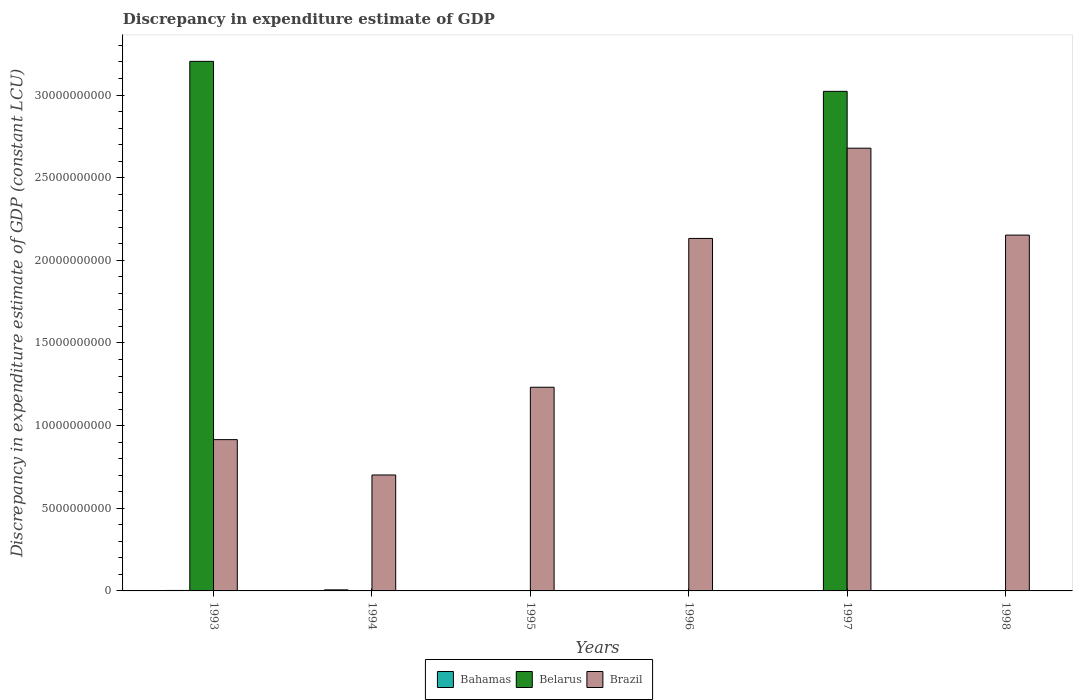How many different coloured bars are there?
Offer a terse response. 3. Are the number of bars per tick equal to the number of legend labels?
Offer a very short reply. No. Are the number of bars on each tick of the X-axis equal?
Offer a very short reply. No. What is the discrepancy in expenditure estimate of GDP in Brazil in 1996?
Your answer should be very brief. 2.13e+1. Across all years, what is the maximum discrepancy in expenditure estimate of GDP in Bahamas?
Make the answer very short. 6.38e+07. Across all years, what is the minimum discrepancy in expenditure estimate of GDP in Brazil?
Your answer should be very brief. 7.01e+09. What is the total discrepancy in expenditure estimate of GDP in Belarus in the graph?
Keep it short and to the point. 6.23e+1. What is the difference between the discrepancy in expenditure estimate of GDP in Belarus in 1993 and that in 1997?
Provide a short and direct response. 1.81e+09. What is the difference between the discrepancy in expenditure estimate of GDP in Belarus in 1998 and the discrepancy in expenditure estimate of GDP in Brazil in 1997?
Provide a succinct answer. -2.68e+1. What is the average discrepancy in expenditure estimate of GDP in Bahamas per year?
Keep it short and to the point. 1.60e+07. In the year 1994, what is the difference between the discrepancy in expenditure estimate of GDP in Bahamas and discrepancy in expenditure estimate of GDP in Brazil?
Make the answer very short. -6.95e+09. In how many years, is the discrepancy in expenditure estimate of GDP in Belarus greater than 27000000000 LCU?
Your answer should be very brief. 2. What is the ratio of the discrepancy in expenditure estimate of GDP in Brazil in 1993 to that in 1996?
Offer a very short reply. 0.43. Is the discrepancy in expenditure estimate of GDP in Brazil in 1994 less than that in 1998?
Give a very brief answer. Yes. What is the difference between the highest and the second highest discrepancy in expenditure estimate of GDP in Bahamas?
Keep it short and to the point. 3.46e+07. What is the difference between the highest and the lowest discrepancy in expenditure estimate of GDP in Bahamas?
Your response must be concise. 6.38e+07. Is it the case that in every year, the sum of the discrepancy in expenditure estimate of GDP in Brazil and discrepancy in expenditure estimate of GDP in Bahamas is greater than the discrepancy in expenditure estimate of GDP in Belarus?
Keep it short and to the point. No. How many bars are there?
Make the answer very short. 12. What is the difference between two consecutive major ticks on the Y-axis?
Your answer should be very brief. 5.00e+09. Are the values on the major ticks of Y-axis written in scientific E-notation?
Offer a terse response. No. Does the graph contain grids?
Offer a very short reply. No. What is the title of the graph?
Your response must be concise. Discrepancy in expenditure estimate of GDP. What is the label or title of the Y-axis?
Provide a short and direct response. Discrepancy in expenditure estimate of GDP (constant LCU). What is the Discrepancy in expenditure estimate of GDP (constant LCU) of Bahamas in 1993?
Your response must be concise. 2.92e+07. What is the Discrepancy in expenditure estimate of GDP (constant LCU) of Belarus in 1993?
Give a very brief answer. 3.20e+1. What is the Discrepancy in expenditure estimate of GDP (constant LCU) in Brazil in 1993?
Ensure brevity in your answer.  9.15e+09. What is the Discrepancy in expenditure estimate of GDP (constant LCU) in Bahamas in 1994?
Provide a succinct answer. 6.38e+07. What is the Discrepancy in expenditure estimate of GDP (constant LCU) in Belarus in 1994?
Offer a very short reply. 0. What is the Discrepancy in expenditure estimate of GDP (constant LCU) in Brazil in 1994?
Your answer should be very brief. 7.01e+09. What is the Discrepancy in expenditure estimate of GDP (constant LCU) in Bahamas in 1995?
Make the answer very short. 3.23e+06. What is the Discrepancy in expenditure estimate of GDP (constant LCU) of Belarus in 1995?
Provide a succinct answer. 0. What is the Discrepancy in expenditure estimate of GDP (constant LCU) of Brazil in 1995?
Offer a very short reply. 1.23e+1. What is the Discrepancy in expenditure estimate of GDP (constant LCU) in Belarus in 1996?
Give a very brief answer. 0. What is the Discrepancy in expenditure estimate of GDP (constant LCU) of Brazil in 1996?
Offer a terse response. 2.13e+1. What is the Discrepancy in expenditure estimate of GDP (constant LCU) of Belarus in 1997?
Offer a very short reply. 3.02e+1. What is the Discrepancy in expenditure estimate of GDP (constant LCU) in Brazil in 1997?
Ensure brevity in your answer.  2.68e+1. What is the Discrepancy in expenditure estimate of GDP (constant LCU) in Bahamas in 1998?
Your answer should be compact. 0. What is the Discrepancy in expenditure estimate of GDP (constant LCU) in Belarus in 1998?
Make the answer very short. 0. What is the Discrepancy in expenditure estimate of GDP (constant LCU) in Brazil in 1998?
Your response must be concise. 2.15e+1. Across all years, what is the maximum Discrepancy in expenditure estimate of GDP (constant LCU) in Bahamas?
Make the answer very short. 6.38e+07. Across all years, what is the maximum Discrepancy in expenditure estimate of GDP (constant LCU) of Belarus?
Offer a terse response. 3.20e+1. Across all years, what is the maximum Discrepancy in expenditure estimate of GDP (constant LCU) in Brazil?
Your answer should be compact. 2.68e+1. Across all years, what is the minimum Discrepancy in expenditure estimate of GDP (constant LCU) of Brazil?
Make the answer very short. 7.01e+09. What is the total Discrepancy in expenditure estimate of GDP (constant LCU) of Bahamas in the graph?
Your response must be concise. 9.62e+07. What is the total Discrepancy in expenditure estimate of GDP (constant LCU) in Belarus in the graph?
Ensure brevity in your answer.  6.23e+1. What is the total Discrepancy in expenditure estimate of GDP (constant LCU) of Brazil in the graph?
Provide a short and direct response. 9.81e+1. What is the difference between the Discrepancy in expenditure estimate of GDP (constant LCU) of Bahamas in 1993 and that in 1994?
Your response must be concise. -3.46e+07. What is the difference between the Discrepancy in expenditure estimate of GDP (constant LCU) in Brazil in 1993 and that in 1994?
Your answer should be very brief. 2.14e+09. What is the difference between the Discrepancy in expenditure estimate of GDP (constant LCU) in Bahamas in 1993 and that in 1995?
Offer a terse response. 2.59e+07. What is the difference between the Discrepancy in expenditure estimate of GDP (constant LCU) of Brazil in 1993 and that in 1995?
Provide a succinct answer. -3.17e+09. What is the difference between the Discrepancy in expenditure estimate of GDP (constant LCU) of Brazil in 1993 and that in 1996?
Offer a terse response. -1.22e+1. What is the difference between the Discrepancy in expenditure estimate of GDP (constant LCU) in Bahamas in 1993 and that in 1997?
Make the answer very short. 2.92e+07. What is the difference between the Discrepancy in expenditure estimate of GDP (constant LCU) in Belarus in 1993 and that in 1997?
Keep it short and to the point. 1.81e+09. What is the difference between the Discrepancy in expenditure estimate of GDP (constant LCU) of Brazil in 1993 and that in 1997?
Provide a succinct answer. -1.76e+1. What is the difference between the Discrepancy in expenditure estimate of GDP (constant LCU) of Brazil in 1993 and that in 1998?
Offer a terse response. -1.24e+1. What is the difference between the Discrepancy in expenditure estimate of GDP (constant LCU) of Bahamas in 1994 and that in 1995?
Your answer should be compact. 6.06e+07. What is the difference between the Discrepancy in expenditure estimate of GDP (constant LCU) in Brazil in 1994 and that in 1995?
Give a very brief answer. -5.31e+09. What is the difference between the Discrepancy in expenditure estimate of GDP (constant LCU) of Brazil in 1994 and that in 1996?
Ensure brevity in your answer.  -1.43e+1. What is the difference between the Discrepancy in expenditure estimate of GDP (constant LCU) of Bahamas in 1994 and that in 1997?
Offer a very short reply. 6.38e+07. What is the difference between the Discrepancy in expenditure estimate of GDP (constant LCU) in Brazil in 1994 and that in 1997?
Keep it short and to the point. -1.98e+1. What is the difference between the Discrepancy in expenditure estimate of GDP (constant LCU) in Brazil in 1994 and that in 1998?
Provide a succinct answer. -1.45e+1. What is the difference between the Discrepancy in expenditure estimate of GDP (constant LCU) of Brazil in 1995 and that in 1996?
Your answer should be very brief. -9.00e+09. What is the difference between the Discrepancy in expenditure estimate of GDP (constant LCU) of Bahamas in 1995 and that in 1997?
Your answer should be compact. 3.22e+06. What is the difference between the Discrepancy in expenditure estimate of GDP (constant LCU) of Brazil in 1995 and that in 1997?
Make the answer very short. -1.45e+1. What is the difference between the Discrepancy in expenditure estimate of GDP (constant LCU) of Brazil in 1995 and that in 1998?
Give a very brief answer. -9.20e+09. What is the difference between the Discrepancy in expenditure estimate of GDP (constant LCU) of Brazil in 1996 and that in 1997?
Your answer should be very brief. -5.46e+09. What is the difference between the Discrepancy in expenditure estimate of GDP (constant LCU) of Brazil in 1996 and that in 1998?
Provide a succinct answer. -2.02e+08. What is the difference between the Discrepancy in expenditure estimate of GDP (constant LCU) in Brazil in 1997 and that in 1998?
Ensure brevity in your answer.  5.26e+09. What is the difference between the Discrepancy in expenditure estimate of GDP (constant LCU) in Bahamas in 1993 and the Discrepancy in expenditure estimate of GDP (constant LCU) in Brazil in 1994?
Provide a short and direct response. -6.98e+09. What is the difference between the Discrepancy in expenditure estimate of GDP (constant LCU) of Belarus in 1993 and the Discrepancy in expenditure estimate of GDP (constant LCU) of Brazil in 1994?
Ensure brevity in your answer.  2.50e+1. What is the difference between the Discrepancy in expenditure estimate of GDP (constant LCU) of Bahamas in 1993 and the Discrepancy in expenditure estimate of GDP (constant LCU) of Brazil in 1995?
Provide a succinct answer. -1.23e+1. What is the difference between the Discrepancy in expenditure estimate of GDP (constant LCU) of Belarus in 1993 and the Discrepancy in expenditure estimate of GDP (constant LCU) of Brazil in 1995?
Ensure brevity in your answer.  1.97e+1. What is the difference between the Discrepancy in expenditure estimate of GDP (constant LCU) in Bahamas in 1993 and the Discrepancy in expenditure estimate of GDP (constant LCU) in Brazil in 1996?
Make the answer very short. -2.13e+1. What is the difference between the Discrepancy in expenditure estimate of GDP (constant LCU) of Belarus in 1993 and the Discrepancy in expenditure estimate of GDP (constant LCU) of Brazil in 1996?
Make the answer very short. 1.07e+1. What is the difference between the Discrepancy in expenditure estimate of GDP (constant LCU) of Bahamas in 1993 and the Discrepancy in expenditure estimate of GDP (constant LCU) of Belarus in 1997?
Your response must be concise. -3.02e+1. What is the difference between the Discrepancy in expenditure estimate of GDP (constant LCU) in Bahamas in 1993 and the Discrepancy in expenditure estimate of GDP (constant LCU) in Brazil in 1997?
Your answer should be compact. -2.68e+1. What is the difference between the Discrepancy in expenditure estimate of GDP (constant LCU) in Belarus in 1993 and the Discrepancy in expenditure estimate of GDP (constant LCU) in Brazil in 1997?
Ensure brevity in your answer.  5.25e+09. What is the difference between the Discrepancy in expenditure estimate of GDP (constant LCU) of Bahamas in 1993 and the Discrepancy in expenditure estimate of GDP (constant LCU) of Brazil in 1998?
Keep it short and to the point. -2.15e+1. What is the difference between the Discrepancy in expenditure estimate of GDP (constant LCU) of Belarus in 1993 and the Discrepancy in expenditure estimate of GDP (constant LCU) of Brazil in 1998?
Provide a short and direct response. 1.05e+1. What is the difference between the Discrepancy in expenditure estimate of GDP (constant LCU) of Bahamas in 1994 and the Discrepancy in expenditure estimate of GDP (constant LCU) of Brazil in 1995?
Your answer should be compact. -1.23e+1. What is the difference between the Discrepancy in expenditure estimate of GDP (constant LCU) of Bahamas in 1994 and the Discrepancy in expenditure estimate of GDP (constant LCU) of Brazil in 1996?
Your answer should be very brief. -2.13e+1. What is the difference between the Discrepancy in expenditure estimate of GDP (constant LCU) in Bahamas in 1994 and the Discrepancy in expenditure estimate of GDP (constant LCU) in Belarus in 1997?
Your answer should be very brief. -3.02e+1. What is the difference between the Discrepancy in expenditure estimate of GDP (constant LCU) in Bahamas in 1994 and the Discrepancy in expenditure estimate of GDP (constant LCU) in Brazil in 1997?
Provide a succinct answer. -2.67e+1. What is the difference between the Discrepancy in expenditure estimate of GDP (constant LCU) of Bahamas in 1994 and the Discrepancy in expenditure estimate of GDP (constant LCU) of Brazil in 1998?
Offer a very short reply. -2.15e+1. What is the difference between the Discrepancy in expenditure estimate of GDP (constant LCU) in Bahamas in 1995 and the Discrepancy in expenditure estimate of GDP (constant LCU) in Brazil in 1996?
Make the answer very short. -2.13e+1. What is the difference between the Discrepancy in expenditure estimate of GDP (constant LCU) of Bahamas in 1995 and the Discrepancy in expenditure estimate of GDP (constant LCU) of Belarus in 1997?
Your answer should be very brief. -3.02e+1. What is the difference between the Discrepancy in expenditure estimate of GDP (constant LCU) in Bahamas in 1995 and the Discrepancy in expenditure estimate of GDP (constant LCU) in Brazil in 1997?
Offer a very short reply. -2.68e+1. What is the difference between the Discrepancy in expenditure estimate of GDP (constant LCU) of Bahamas in 1995 and the Discrepancy in expenditure estimate of GDP (constant LCU) of Brazil in 1998?
Make the answer very short. -2.15e+1. What is the difference between the Discrepancy in expenditure estimate of GDP (constant LCU) in Bahamas in 1997 and the Discrepancy in expenditure estimate of GDP (constant LCU) in Brazil in 1998?
Offer a terse response. -2.15e+1. What is the difference between the Discrepancy in expenditure estimate of GDP (constant LCU) in Belarus in 1997 and the Discrepancy in expenditure estimate of GDP (constant LCU) in Brazil in 1998?
Offer a terse response. 8.70e+09. What is the average Discrepancy in expenditure estimate of GDP (constant LCU) in Bahamas per year?
Ensure brevity in your answer.  1.60e+07. What is the average Discrepancy in expenditure estimate of GDP (constant LCU) of Belarus per year?
Your answer should be compact. 1.04e+1. What is the average Discrepancy in expenditure estimate of GDP (constant LCU) in Brazil per year?
Your answer should be very brief. 1.64e+1. In the year 1993, what is the difference between the Discrepancy in expenditure estimate of GDP (constant LCU) in Bahamas and Discrepancy in expenditure estimate of GDP (constant LCU) in Belarus?
Offer a very short reply. -3.20e+1. In the year 1993, what is the difference between the Discrepancy in expenditure estimate of GDP (constant LCU) of Bahamas and Discrepancy in expenditure estimate of GDP (constant LCU) of Brazil?
Offer a very short reply. -9.12e+09. In the year 1993, what is the difference between the Discrepancy in expenditure estimate of GDP (constant LCU) in Belarus and Discrepancy in expenditure estimate of GDP (constant LCU) in Brazil?
Ensure brevity in your answer.  2.29e+1. In the year 1994, what is the difference between the Discrepancy in expenditure estimate of GDP (constant LCU) in Bahamas and Discrepancy in expenditure estimate of GDP (constant LCU) in Brazil?
Your answer should be compact. -6.95e+09. In the year 1995, what is the difference between the Discrepancy in expenditure estimate of GDP (constant LCU) of Bahamas and Discrepancy in expenditure estimate of GDP (constant LCU) of Brazil?
Keep it short and to the point. -1.23e+1. In the year 1997, what is the difference between the Discrepancy in expenditure estimate of GDP (constant LCU) in Bahamas and Discrepancy in expenditure estimate of GDP (constant LCU) in Belarus?
Provide a succinct answer. -3.02e+1. In the year 1997, what is the difference between the Discrepancy in expenditure estimate of GDP (constant LCU) in Bahamas and Discrepancy in expenditure estimate of GDP (constant LCU) in Brazil?
Your response must be concise. -2.68e+1. In the year 1997, what is the difference between the Discrepancy in expenditure estimate of GDP (constant LCU) of Belarus and Discrepancy in expenditure estimate of GDP (constant LCU) of Brazil?
Your answer should be compact. 3.44e+09. What is the ratio of the Discrepancy in expenditure estimate of GDP (constant LCU) of Bahamas in 1993 to that in 1994?
Your answer should be compact. 0.46. What is the ratio of the Discrepancy in expenditure estimate of GDP (constant LCU) in Brazil in 1993 to that in 1994?
Provide a succinct answer. 1.3. What is the ratio of the Discrepancy in expenditure estimate of GDP (constant LCU) of Bahamas in 1993 to that in 1995?
Your response must be concise. 9.04. What is the ratio of the Discrepancy in expenditure estimate of GDP (constant LCU) in Brazil in 1993 to that in 1995?
Your answer should be compact. 0.74. What is the ratio of the Discrepancy in expenditure estimate of GDP (constant LCU) in Brazil in 1993 to that in 1996?
Your answer should be very brief. 0.43. What is the ratio of the Discrepancy in expenditure estimate of GDP (constant LCU) in Bahamas in 1993 to that in 1997?
Your answer should be compact. 1.46e+04. What is the ratio of the Discrepancy in expenditure estimate of GDP (constant LCU) of Belarus in 1993 to that in 1997?
Make the answer very short. 1.06. What is the ratio of the Discrepancy in expenditure estimate of GDP (constant LCU) of Brazil in 1993 to that in 1997?
Provide a short and direct response. 0.34. What is the ratio of the Discrepancy in expenditure estimate of GDP (constant LCU) in Brazil in 1993 to that in 1998?
Offer a very short reply. 0.43. What is the ratio of the Discrepancy in expenditure estimate of GDP (constant LCU) in Bahamas in 1994 to that in 1995?
Provide a short and direct response. 19.78. What is the ratio of the Discrepancy in expenditure estimate of GDP (constant LCU) of Brazil in 1994 to that in 1995?
Provide a short and direct response. 0.57. What is the ratio of the Discrepancy in expenditure estimate of GDP (constant LCU) in Brazil in 1994 to that in 1996?
Keep it short and to the point. 0.33. What is the ratio of the Discrepancy in expenditure estimate of GDP (constant LCU) in Bahamas in 1994 to that in 1997?
Keep it short and to the point. 3.19e+04. What is the ratio of the Discrepancy in expenditure estimate of GDP (constant LCU) in Brazil in 1994 to that in 1997?
Your answer should be very brief. 0.26. What is the ratio of the Discrepancy in expenditure estimate of GDP (constant LCU) in Brazil in 1994 to that in 1998?
Offer a terse response. 0.33. What is the ratio of the Discrepancy in expenditure estimate of GDP (constant LCU) of Brazil in 1995 to that in 1996?
Ensure brevity in your answer.  0.58. What is the ratio of the Discrepancy in expenditure estimate of GDP (constant LCU) of Bahamas in 1995 to that in 1997?
Give a very brief answer. 1612.65. What is the ratio of the Discrepancy in expenditure estimate of GDP (constant LCU) of Brazil in 1995 to that in 1997?
Give a very brief answer. 0.46. What is the ratio of the Discrepancy in expenditure estimate of GDP (constant LCU) in Brazil in 1995 to that in 1998?
Ensure brevity in your answer.  0.57. What is the ratio of the Discrepancy in expenditure estimate of GDP (constant LCU) of Brazil in 1996 to that in 1997?
Your response must be concise. 0.8. What is the ratio of the Discrepancy in expenditure estimate of GDP (constant LCU) in Brazil in 1996 to that in 1998?
Keep it short and to the point. 0.99. What is the ratio of the Discrepancy in expenditure estimate of GDP (constant LCU) of Brazil in 1997 to that in 1998?
Your answer should be very brief. 1.24. What is the difference between the highest and the second highest Discrepancy in expenditure estimate of GDP (constant LCU) of Bahamas?
Make the answer very short. 3.46e+07. What is the difference between the highest and the second highest Discrepancy in expenditure estimate of GDP (constant LCU) of Brazil?
Provide a succinct answer. 5.26e+09. What is the difference between the highest and the lowest Discrepancy in expenditure estimate of GDP (constant LCU) of Bahamas?
Make the answer very short. 6.38e+07. What is the difference between the highest and the lowest Discrepancy in expenditure estimate of GDP (constant LCU) in Belarus?
Your response must be concise. 3.20e+1. What is the difference between the highest and the lowest Discrepancy in expenditure estimate of GDP (constant LCU) in Brazil?
Your answer should be very brief. 1.98e+1. 